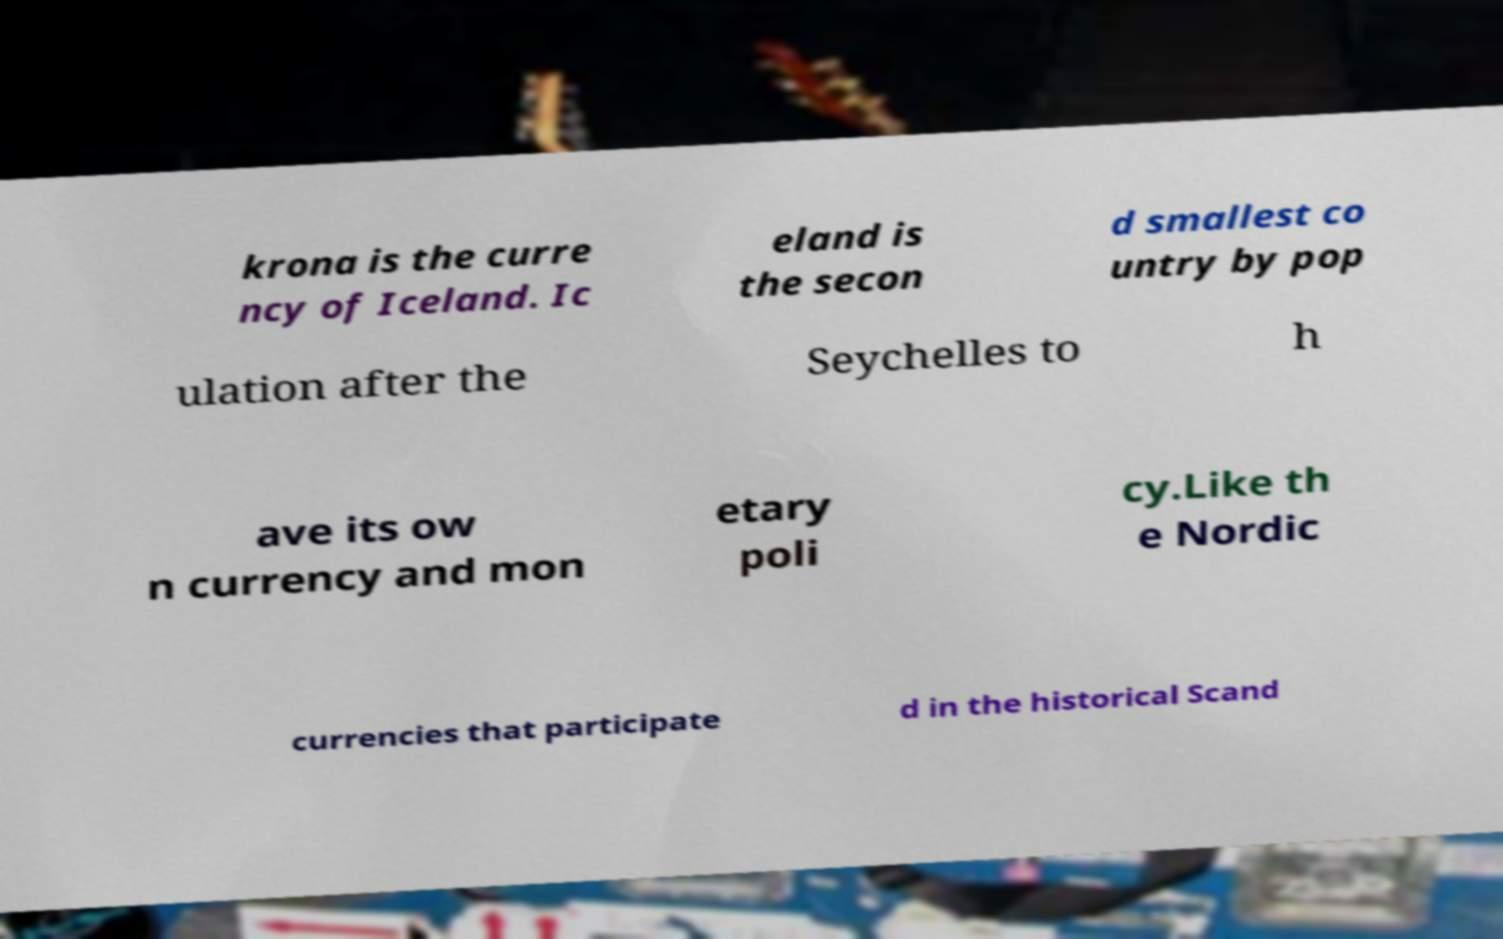Can you read and provide the text displayed in the image?This photo seems to have some interesting text. Can you extract and type it out for me? krona is the curre ncy of Iceland. Ic eland is the secon d smallest co untry by pop ulation after the Seychelles to h ave its ow n currency and mon etary poli cy.Like th e Nordic currencies that participate d in the historical Scand 